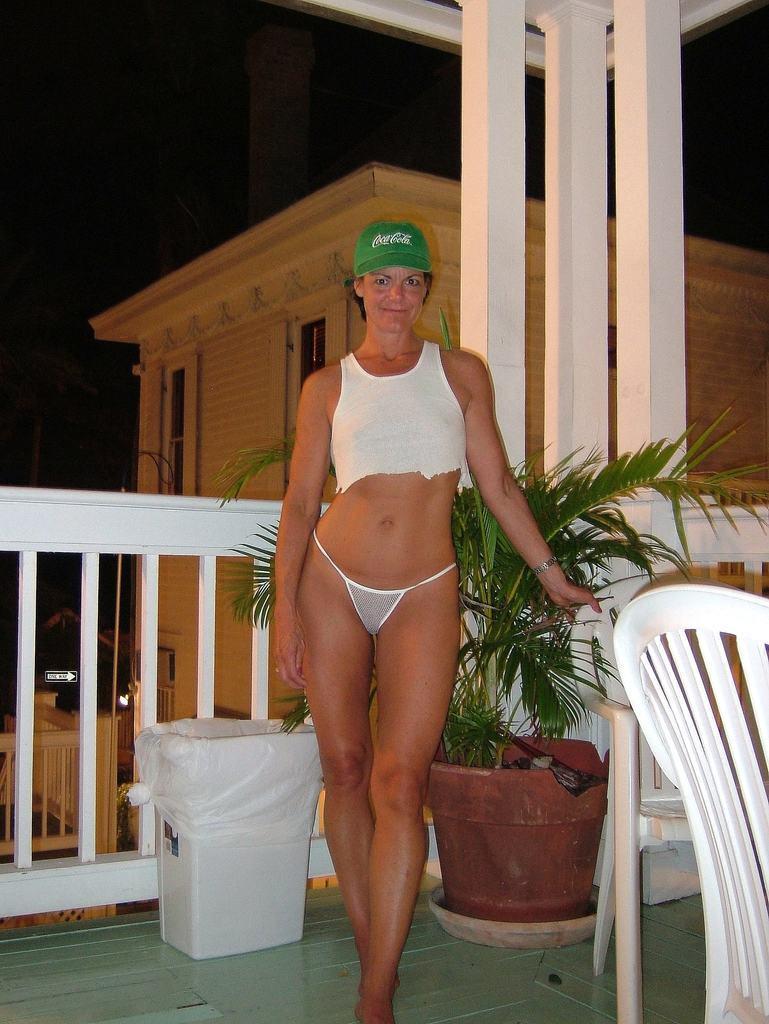In one or two sentences, can you explain what this image depicts? In the image we can see there is a woman standing and she is wearing green colour cap. There is plant kept in the pot and there is chair kept on the floor. Behind there is a building. 